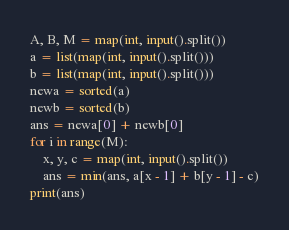Convert code to text. <code><loc_0><loc_0><loc_500><loc_500><_Python_>A, B, M = map(int, input().split())
a = list(map(int, input().split()))
b = list(map(int, input().split()))
newa = sorted(a)
newb = sorted(b)
ans = newa[0] + newb[0]
for i in range(M):
    x, y, c = map(int, input().split())
    ans = min(ans, a[x - 1] + b[y - 1] - c)
print(ans)
</code> 